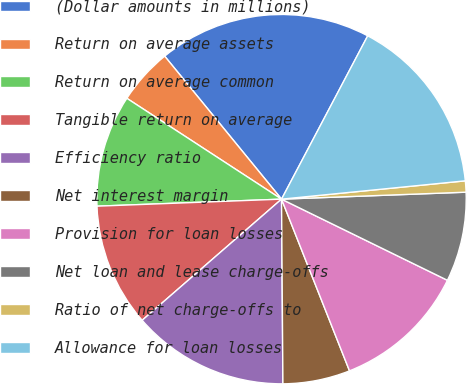Convert chart to OTSL. <chart><loc_0><loc_0><loc_500><loc_500><pie_chart><fcel>(Dollar amounts in millions)<fcel>Return on average assets<fcel>Return on average common<fcel>Tangible return on average<fcel>Efficiency ratio<fcel>Net interest margin<fcel>Provision for loan losses<fcel>Net loan and lease charge-offs<fcel>Ratio of net charge-offs to<fcel>Allowance for loan losses<nl><fcel>18.63%<fcel>4.9%<fcel>9.8%<fcel>10.78%<fcel>13.73%<fcel>5.88%<fcel>11.76%<fcel>7.84%<fcel>0.98%<fcel>15.69%<nl></chart> 